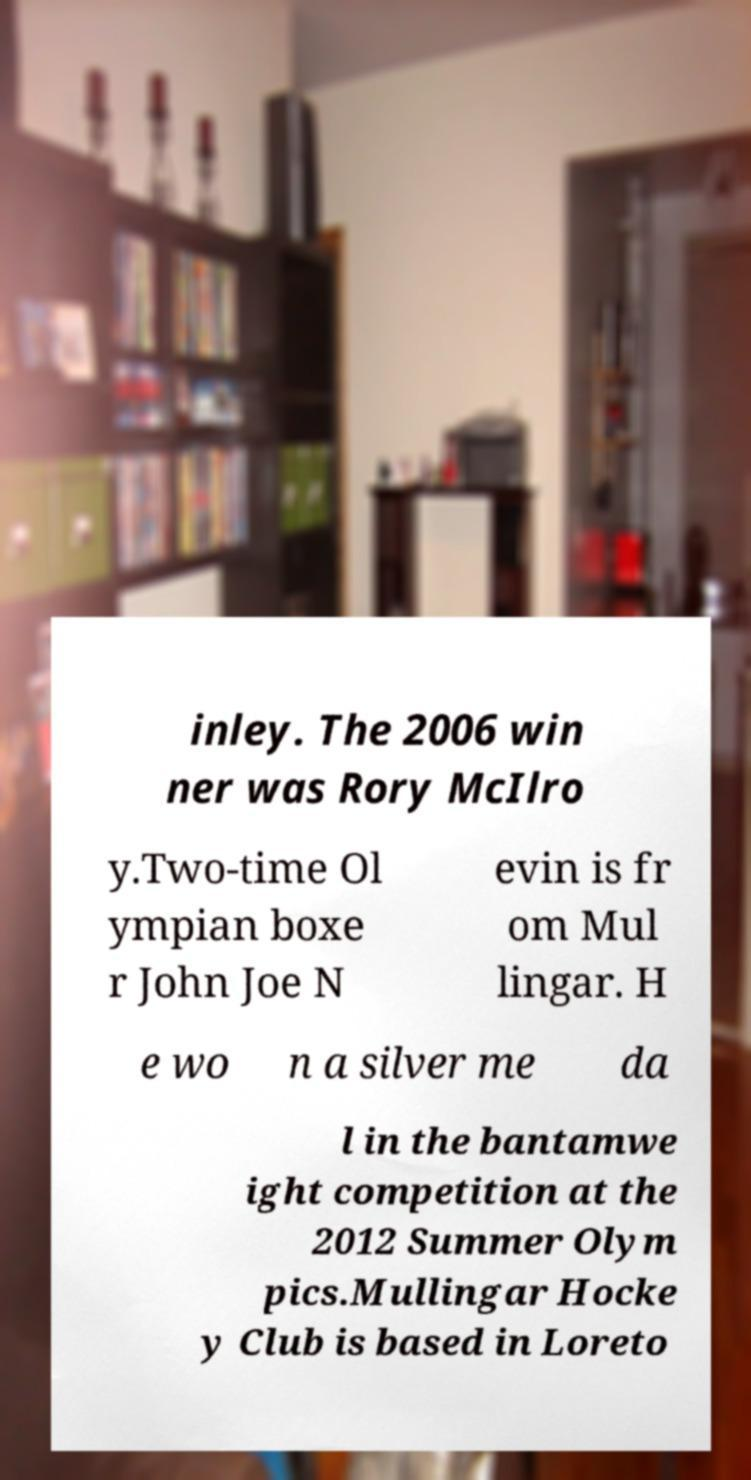Can you accurately transcribe the text from the provided image for me? inley. The 2006 win ner was Rory McIlro y.Two-time Ol ympian boxe r John Joe N evin is fr om Mul lingar. H e wo n a silver me da l in the bantamwe ight competition at the 2012 Summer Olym pics.Mullingar Hocke y Club is based in Loreto 